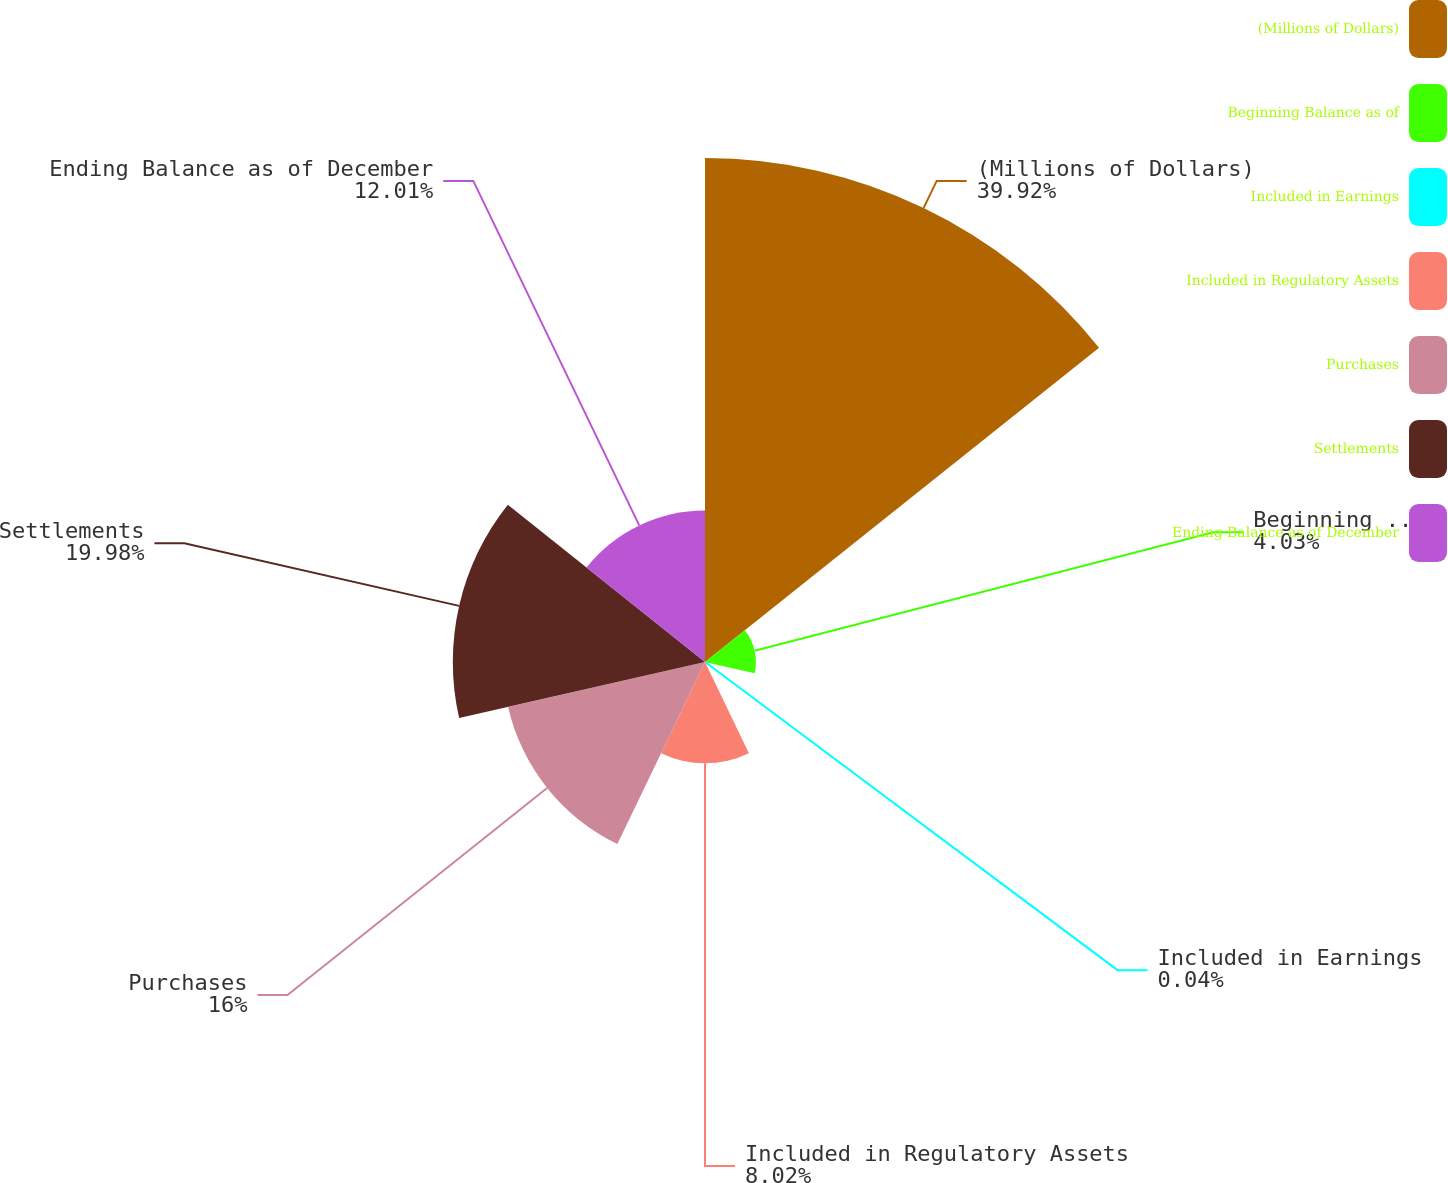<chart> <loc_0><loc_0><loc_500><loc_500><pie_chart><fcel>(Millions of Dollars)<fcel>Beginning Balance as of<fcel>Included in Earnings<fcel>Included in Regulatory Assets<fcel>Purchases<fcel>Settlements<fcel>Ending Balance as of December<nl><fcel>39.93%<fcel>4.03%<fcel>0.04%<fcel>8.02%<fcel>16.0%<fcel>19.98%<fcel>12.01%<nl></chart> 